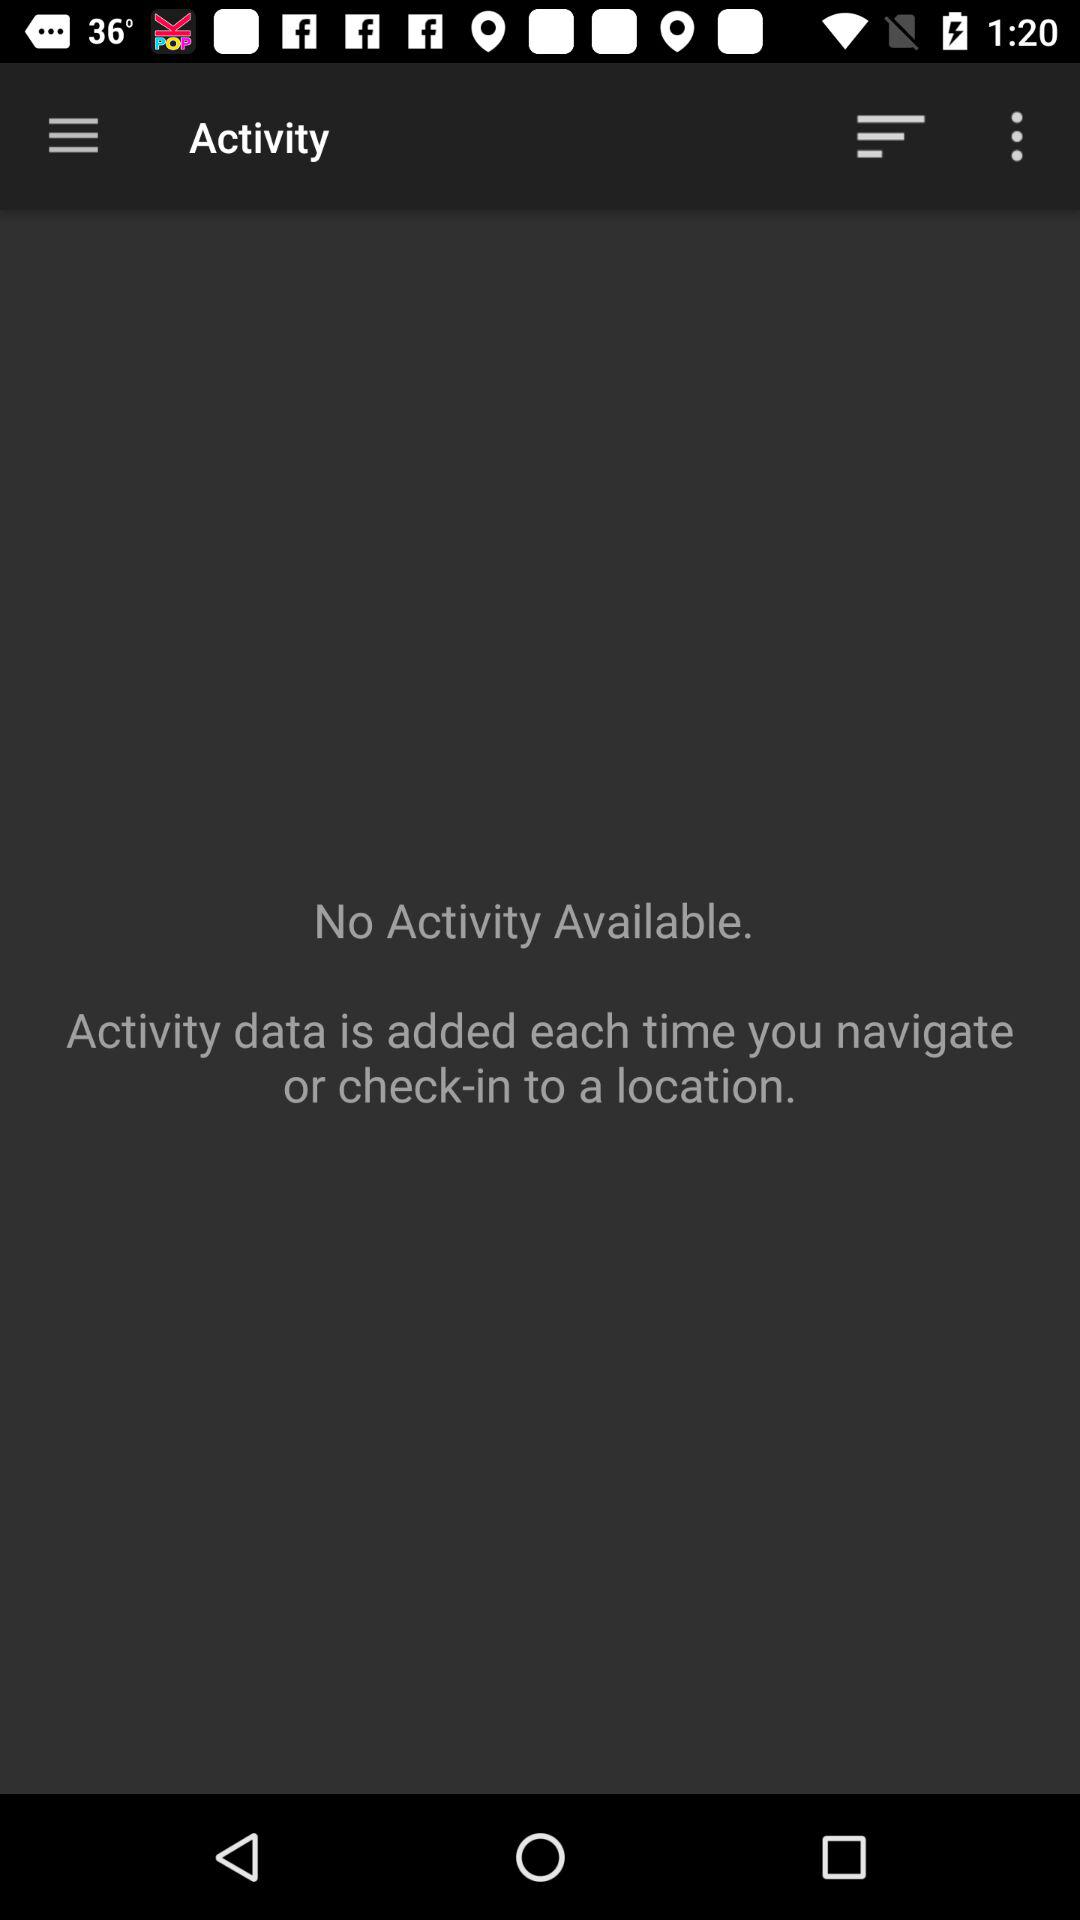How many activities are available? There are no activities available. 